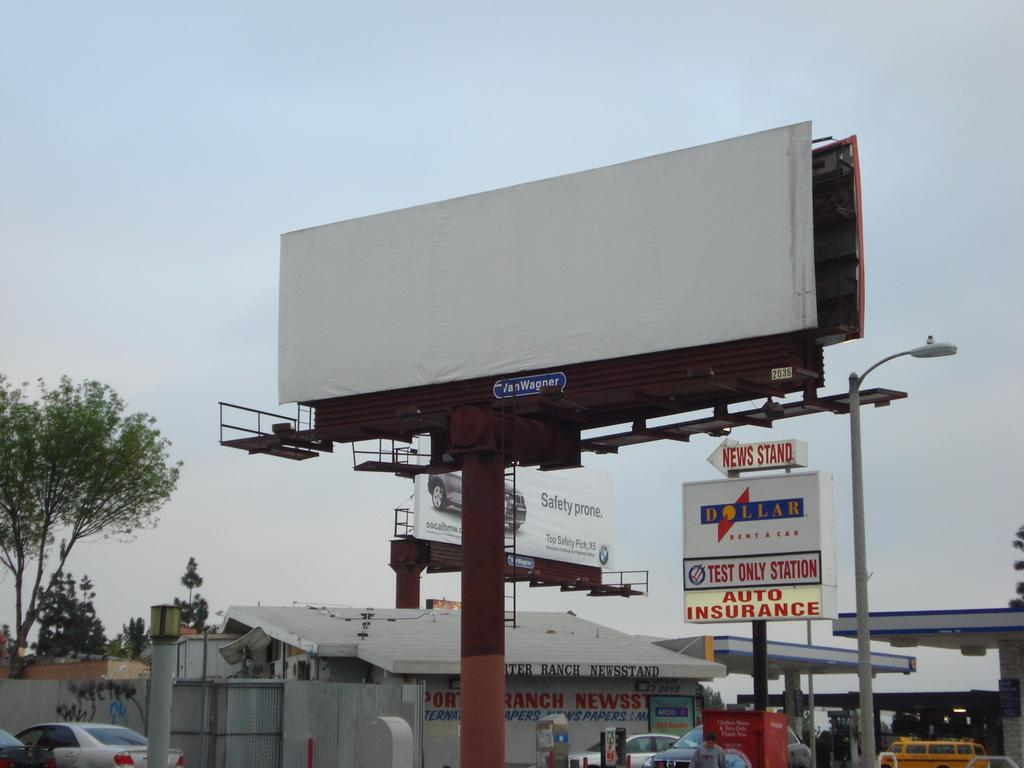<image>
Create a compact narrative representing the image presented. An arrow sign is pointed left to the news stand. 